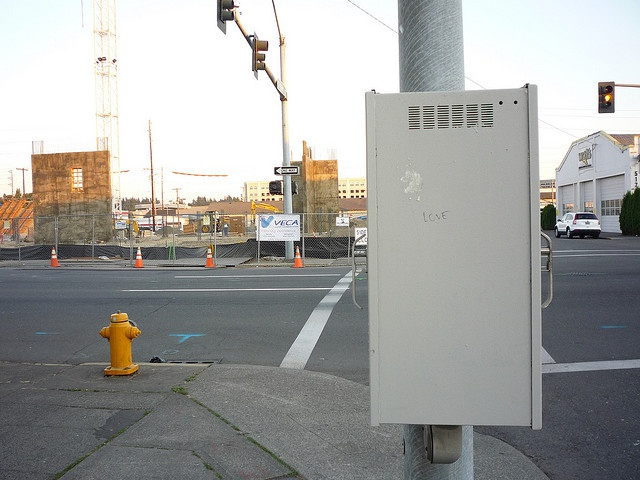Describe the objects in this image and their specific colors. I can see fire hydrant in white, olive, orange, and maroon tones, car in white, lightgray, black, darkgray, and gray tones, traffic light in white, gray, and black tones, traffic light in white, gray, and maroon tones, and traffic light in white, gray, and black tones in this image. 